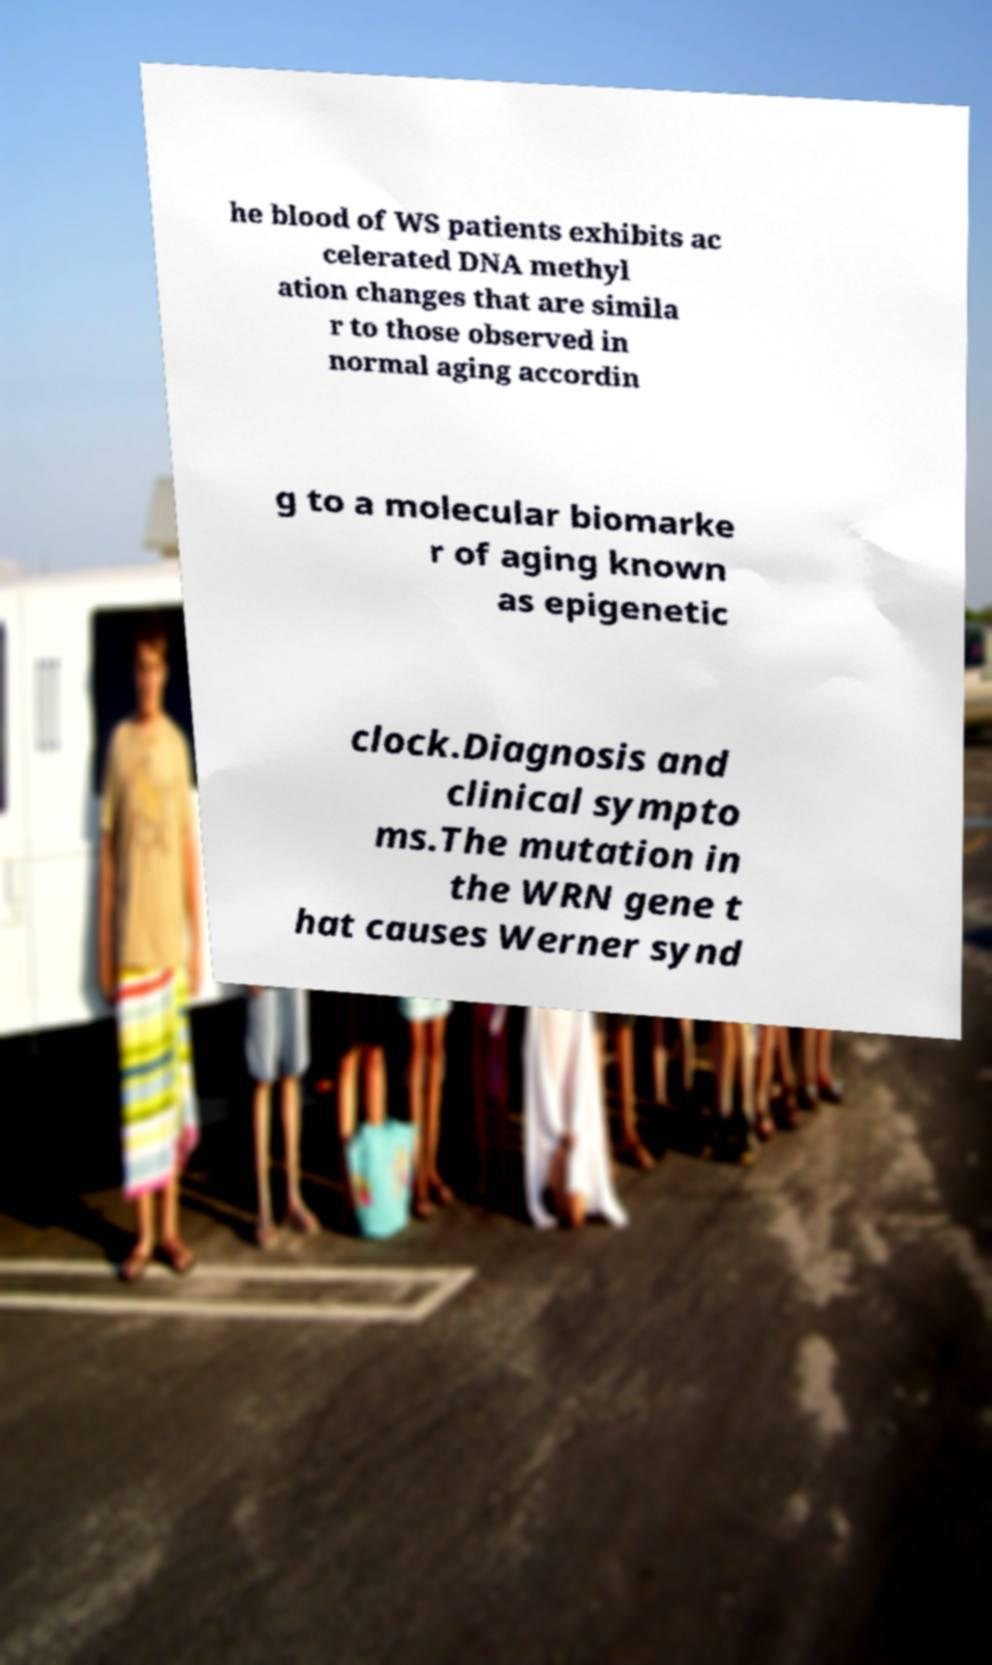What messages or text are displayed in this image? I need them in a readable, typed format. he blood of WS patients exhibits ac celerated DNA methyl ation changes that are simila r to those observed in normal aging accordin g to a molecular biomarke r of aging known as epigenetic clock.Diagnosis and clinical sympto ms.The mutation in the WRN gene t hat causes Werner synd 